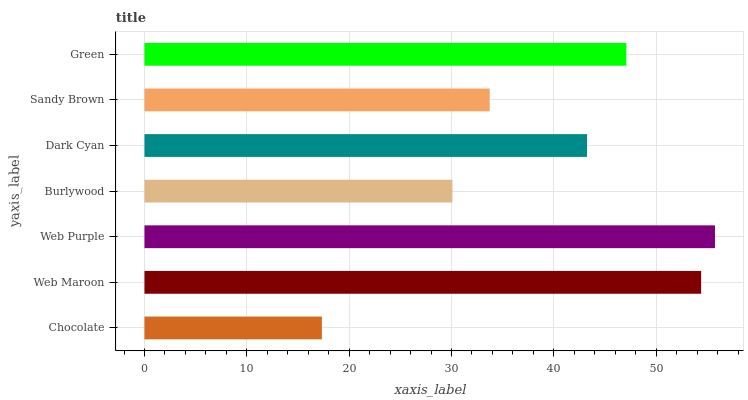Is Chocolate the minimum?
Answer yes or no. Yes. Is Web Purple the maximum?
Answer yes or no. Yes. Is Web Maroon the minimum?
Answer yes or no. No. Is Web Maroon the maximum?
Answer yes or no. No. Is Web Maroon greater than Chocolate?
Answer yes or no. Yes. Is Chocolate less than Web Maroon?
Answer yes or no. Yes. Is Chocolate greater than Web Maroon?
Answer yes or no. No. Is Web Maroon less than Chocolate?
Answer yes or no. No. Is Dark Cyan the high median?
Answer yes or no. Yes. Is Dark Cyan the low median?
Answer yes or no. Yes. Is Sandy Brown the high median?
Answer yes or no. No. Is Web Maroon the low median?
Answer yes or no. No. 